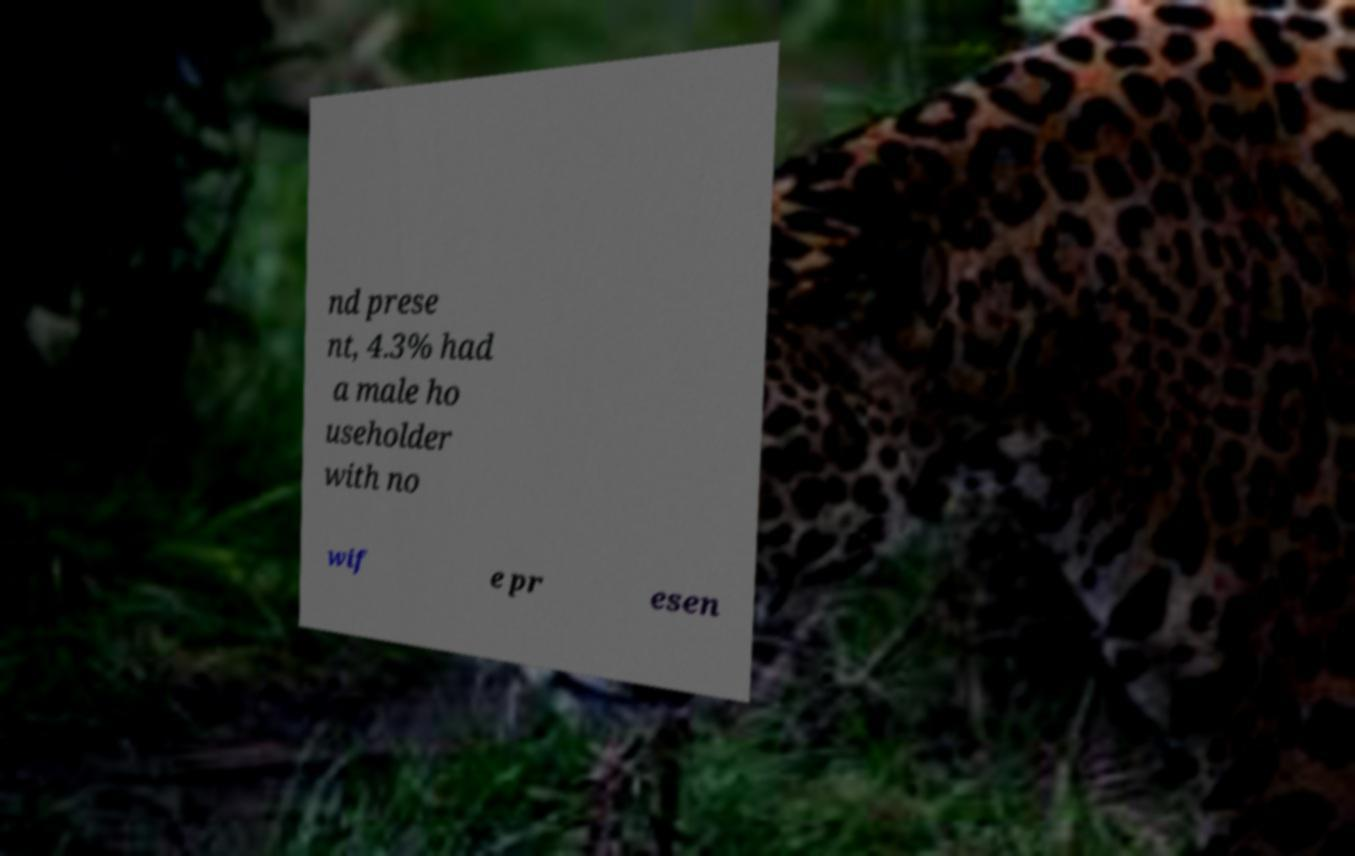For documentation purposes, I need the text within this image transcribed. Could you provide that? nd prese nt, 4.3% had a male ho useholder with no wif e pr esen 